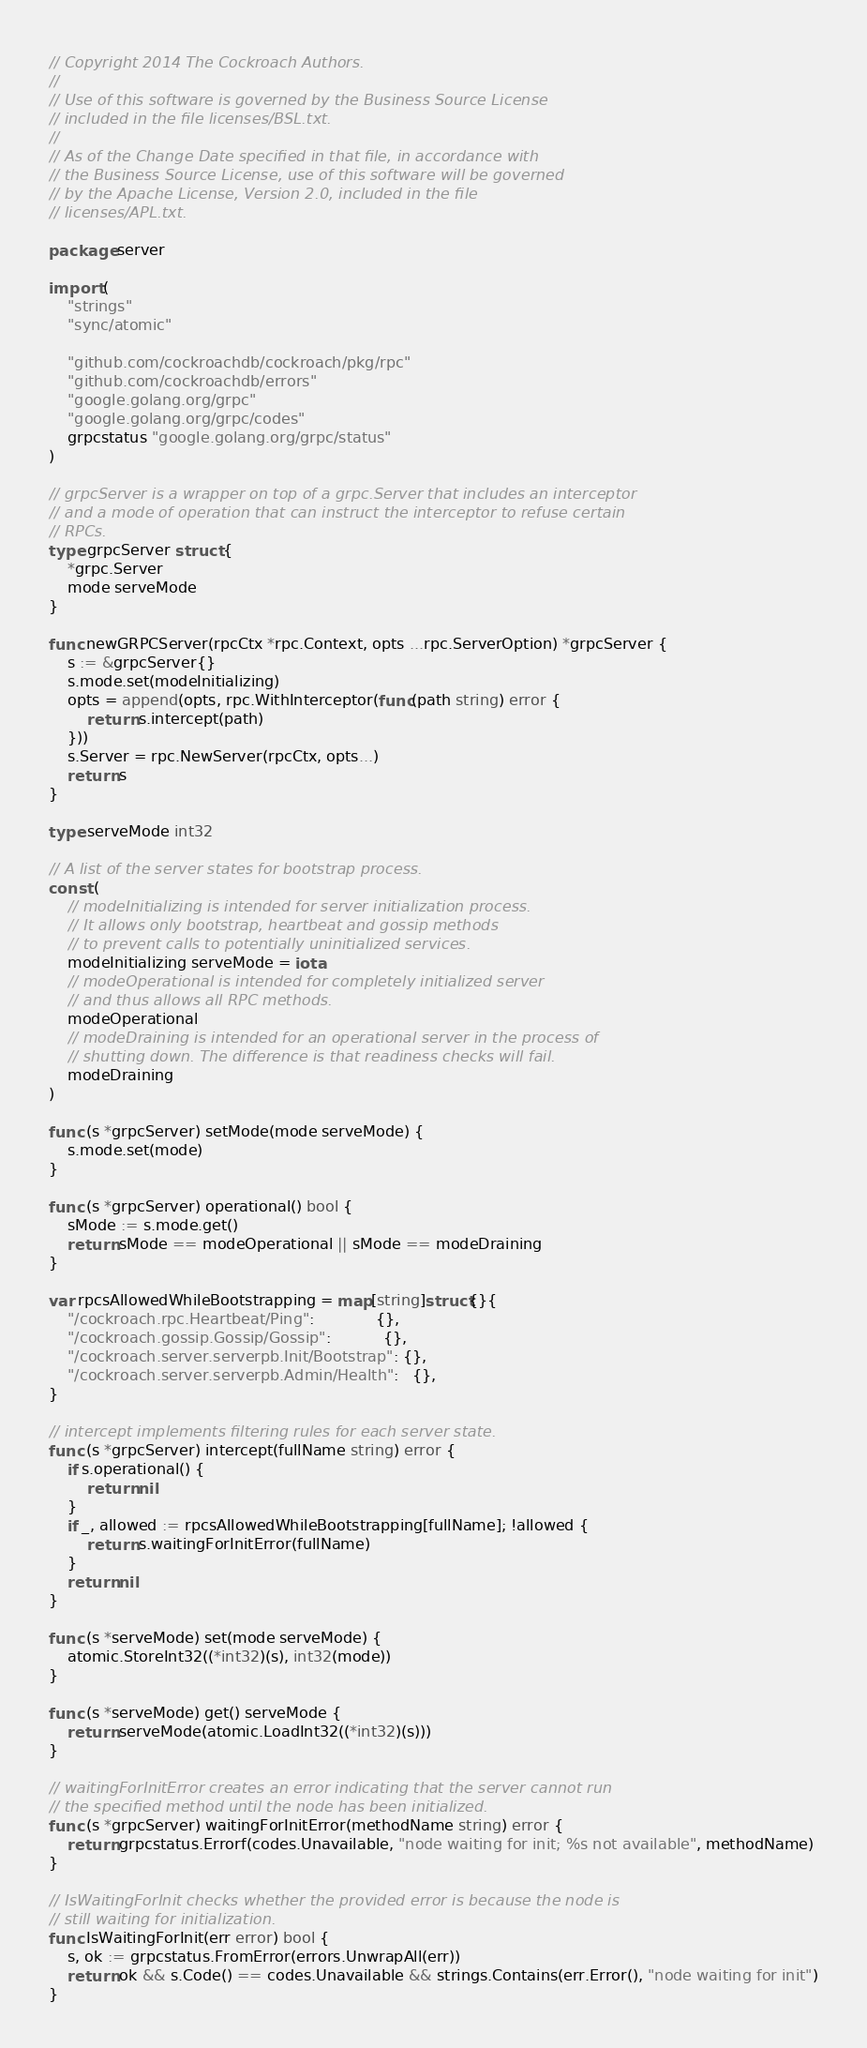Convert code to text. <code><loc_0><loc_0><loc_500><loc_500><_Go_>// Copyright 2014 The Cockroach Authors.
//
// Use of this software is governed by the Business Source License
// included in the file licenses/BSL.txt.
//
// As of the Change Date specified in that file, in accordance with
// the Business Source License, use of this software will be governed
// by the Apache License, Version 2.0, included in the file
// licenses/APL.txt.

package server

import (
	"strings"
	"sync/atomic"

	"github.com/cockroachdb/cockroach/pkg/rpc"
	"github.com/cockroachdb/errors"
	"google.golang.org/grpc"
	"google.golang.org/grpc/codes"
	grpcstatus "google.golang.org/grpc/status"
)

// grpcServer is a wrapper on top of a grpc.Server that includes an interceptor
// and a mode of operation that can instruct the interceptor to refuse certain
// RPCs.
type grpcServer struct {
	*grpc.Server
	mode serveMode
}

func newGRPCServer(rpcCtx *rpc.Context, opts ...rpc.ServerOption) *grpcServer {
	s := &grpcServer{}
	s.mode.set(modeInitializing)
	opts = append(opts, rpc.WithInterceptor(func(path string) error {
		return s.intercept(path)
	}))
	s.Server = rpc.NewServer(rpcCtx, opts...)
	return s
}

type serveMode int32

// A list of the server states for bootstrap process.
const (
	// modeInitializing is intended for server initialization process.
	// It allows only bootstrap, heartbeat and gossip methods
	// to prevent calls to potentially uninitialized services.
	modeInitializing serveMode = iota
	// modeOperational is intended for completely initialized server
	// and thus allows all RPC methods.
	modeOperational
	// modeDraining is intended for an operational server in the process of
	// shutting down. The difference is that readiness checks will fail.
	modeDraining
)

func (s *grpcServer) setMode(mode serveMode) {
	s.mode.set(mode)
}

func (s *grpcServer) operational() bool {
	sMode := s.mode.get()
	return sMode == modeOperational || sMode == modeDraining
}

var rpcsAllowedWhileBootstrapping = map[string]struct{}{
	"/cockroach.rpc.Heartbeat/Ping":             {},
	"/cockroach.gossip.Gossip/Gossip":           {},
	"/cockroach.server.serverpb.Init/Bootstrap": {},
	"/cockroach.server.serverpb.Admin/Health":   {},
}

// intercept implements filtering rules for each server state.
func (s *grpcServer) intercept(fullName string) error {
	if s.operational() {
		return nil
	}
	if _, allowed := rpcsAllowedWhileBootstrapping[fullName]; !allowed {
		return s.waitingForInitError(fullName)
	}
	return nil
}

func (s *serveMode) set(mode serveMode) {
	atomic.StoreInt32((*int32)(s), int32(mode))
}

func (s *serveMode) get() serveMode {
	return serveMode(atomic.LoadInt32((*int32)(s)))
}

// waitingForInitError creates an error indicating that the server cannot run
// the specified method until the node has been initialized.
func (s *grpcServer) waitingForInitError(methodName string) error {
	return grpcstatus.Errorf(codes.Unavailable, "node waiting for init; %s not available", methodName)
}

// IsWaitingForInit checks whether the provided error is because the node is
// still waiting for initialization.
func IsWaitingForInit(err error) bool {
	s, ok := grpcstatus.FromError(errors.UnwrapAll(err))
	return ok && s.Code() == codes.Unavailable && strings.Contains(err.Error(), "node waiting for init")
}
</code> 